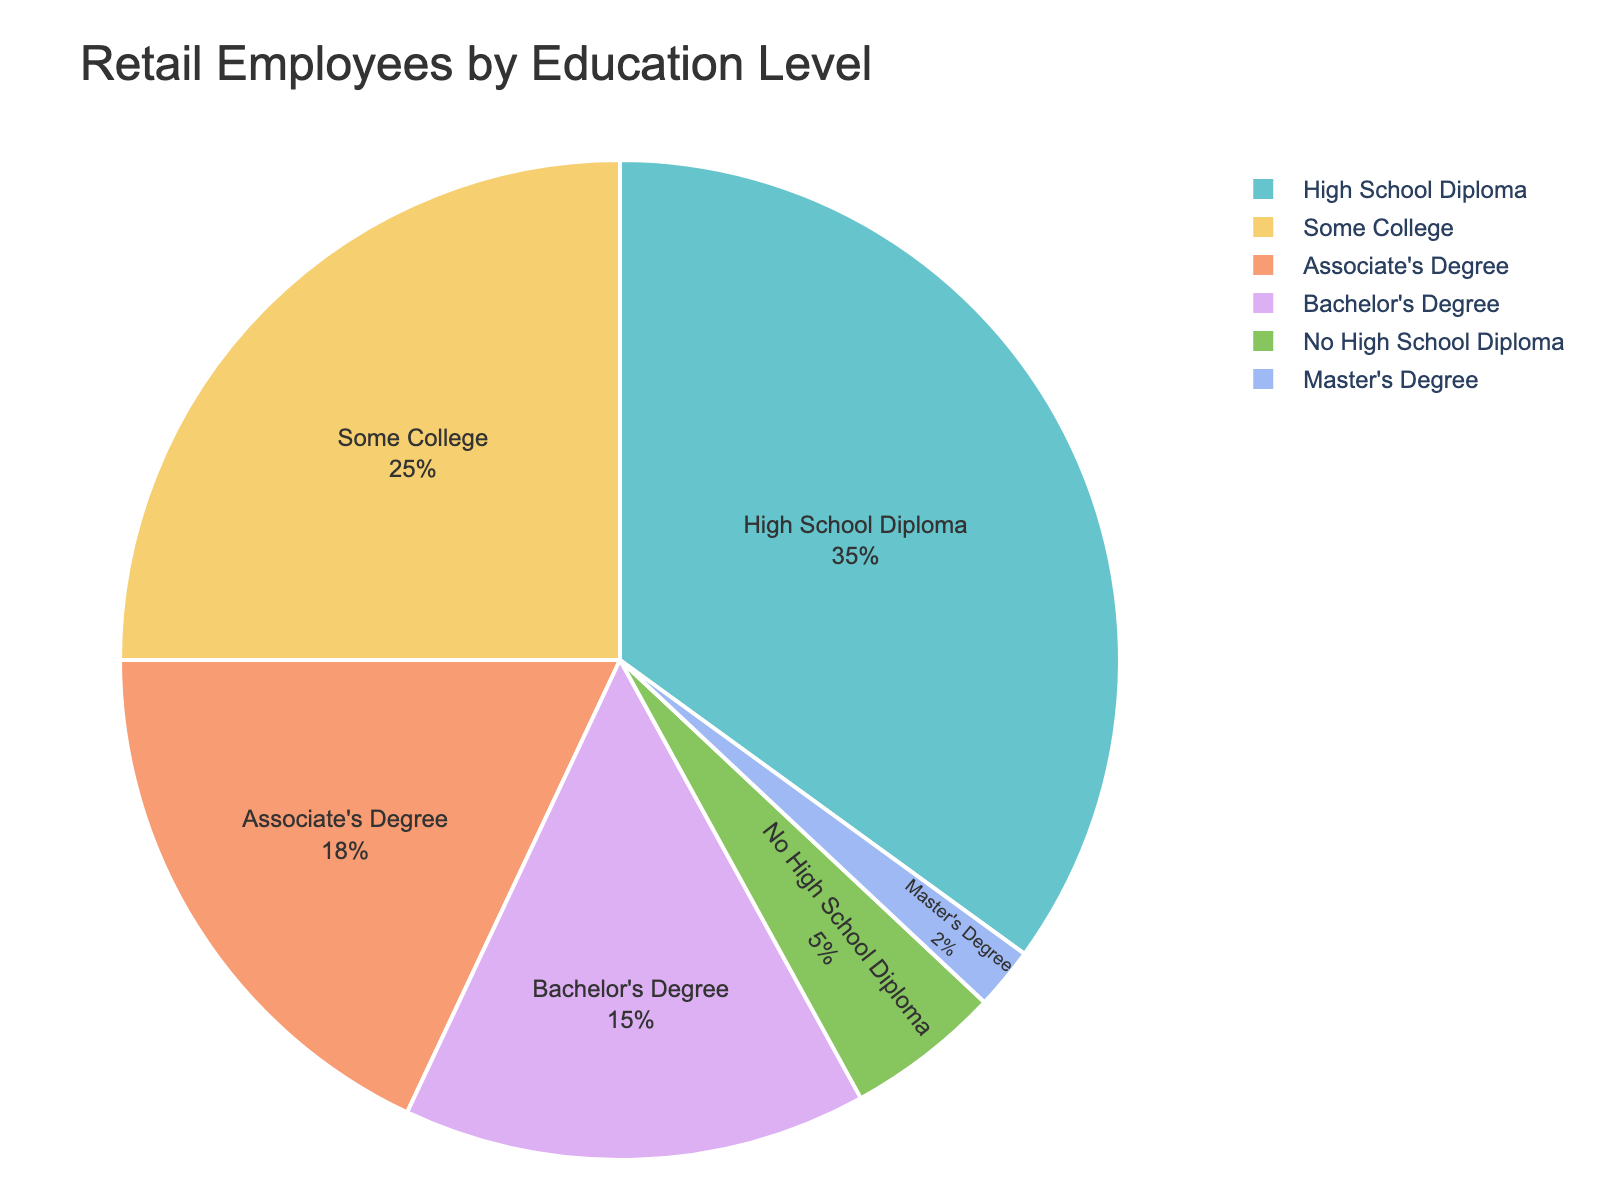What percentage of retail employees have a Bachelor's Degree or higher education? Add the percentage of employees with a Bachelor's Degree (15%) and those with a Master's Degree (2%) to find the total percentage of employees with a Bachelor's Degree or higher education. 15% + 2% = 17%
Answer: 17% Which education level has the highest representation among retail employees? Identify the education level that corresponds to the largest percentage in the chart, which is High School Diploma at 35%. This can be seen from the segment size and corresponding percentage in the pie chart.
Answer: High School Diploma How does the percentage of employees with Some College compare to those with an Associate's Degree? Compare the given percentages: Some College is 25% and Associate's Degree is 18%. Since 25% is greater than 18%, there are more employees with Some College than those with an Associate's Degree.
Answer: Some College has a higher percentage What's the combined share of retail employees without any college education? Sum the percentages of employees with No High School Diploma (5%) and High School Diploma (35%) to find the total percentage without any college education. 5% + 35% = 40%
Answer: 40% Which category makes up the smallest percentage of retail employees? Identify the smallest segment in the pie chart, which corresponds to Master's Degree at 2%. This can be confirmed by the percentage values listed.
Answer: Master's Degree What is the difference in percentage between employees with a High School Diploma and those with a Bachelor's Degree? Subtract the percentage of employees with a Bachelor's Degree (15%) from the percentage of those with a High School Diploma (35%). 35% - 15% = 20%
Answer: 20% How many times larger is the percentage of employees with a High School Diploma compared to those with a Master's Degree? Divide the percentage of employees with a High School Diploma (35%) by the percentage of those with a Master's Degree (2%). 35 / 2 = 17.5
Answer: 17.5 times larger Which education levels have less than 10% of employees each? Identify the segments with percentages less than 10% from the chart, which are No High School Diploma (5%) and Master's Degree (2%).
Answer: No High School Diploma, Master's Degree 